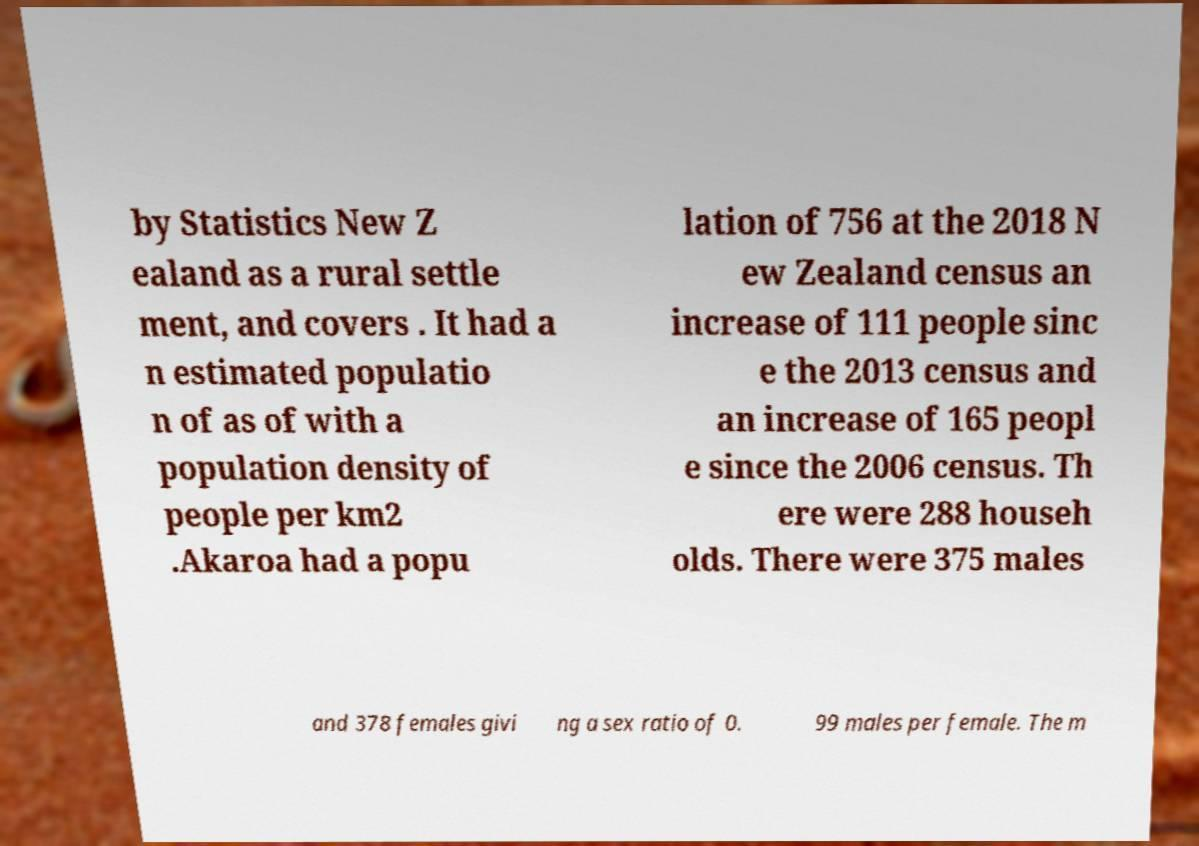I need the written content from this picture converted into text. Can you do that? by Statistics New Z ealand as a rural settle ment, and covers . It had a n estimated populatio n of as of with a population density of people per km2 .Akaroa had a popu lation of 756 at the 2018 N ew Zealand census an increase of 111 people sinc e the 2013 census and an increase of 165 peopl e since the 2006 census. Th ere were 288 househ olds. There were 375 males and 378 females givi ng a sex ratio of 0. 99 males per female. The m 